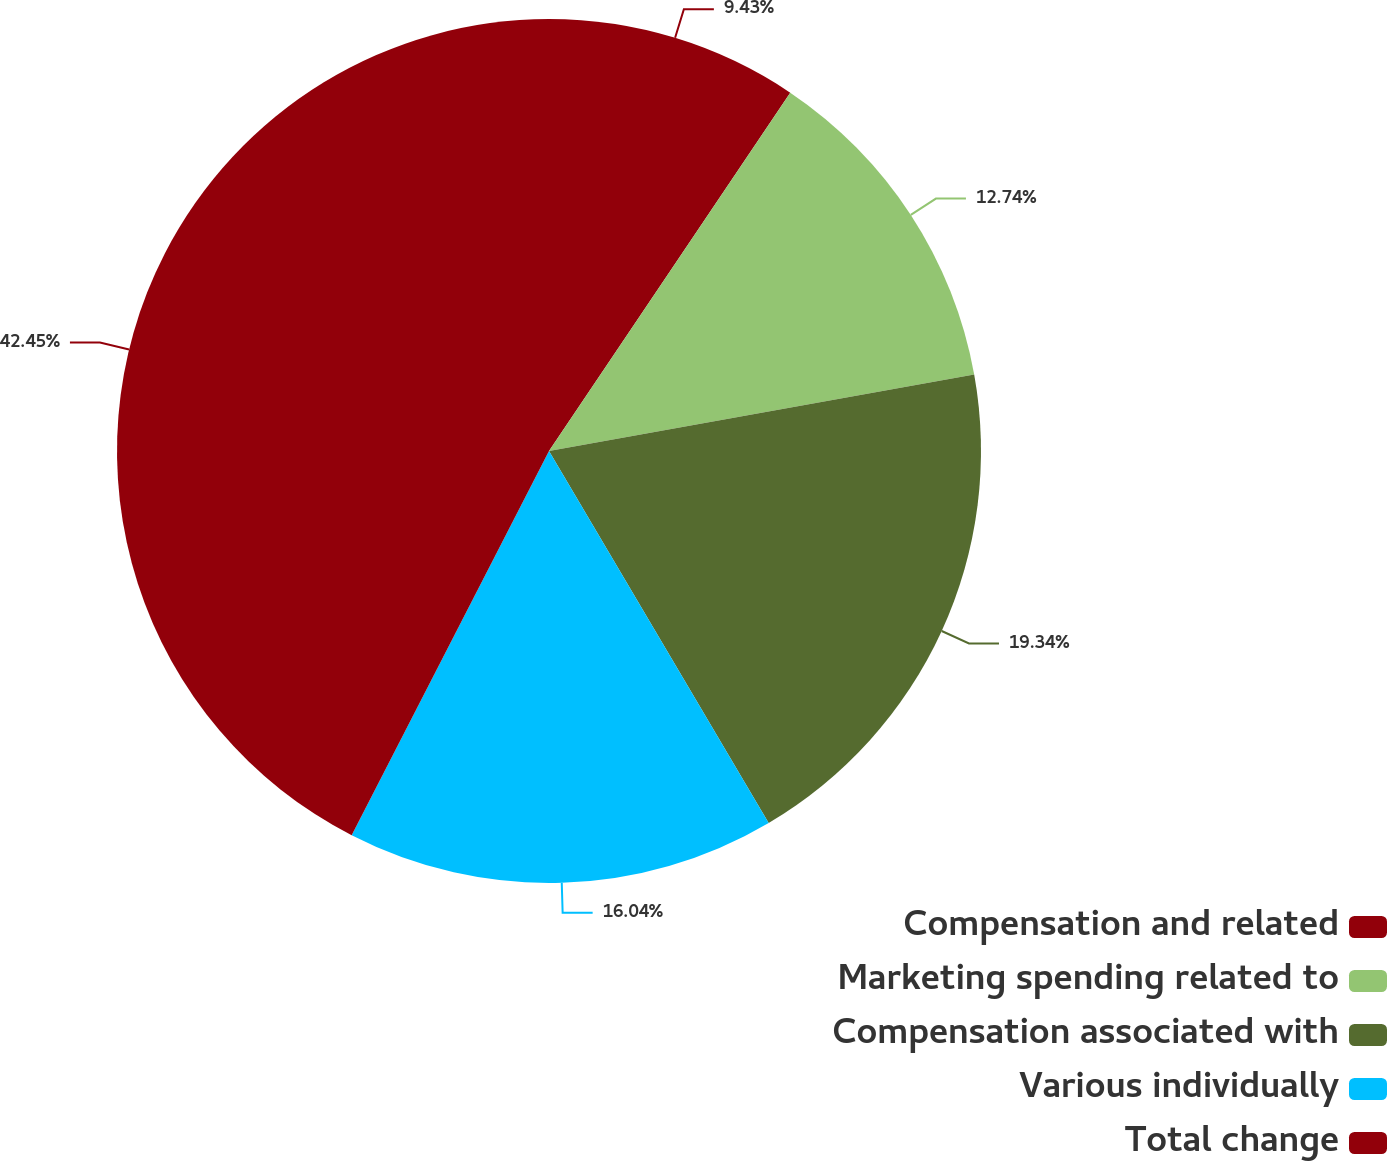Convert chart. <chart><loc_0><loc_0><loc_500><loc_500><pie_chart><fcel>Compensation and related<fcel>Marketing spending related to<fcel>Compensation associated with<fcel>Various individually<fcel>Total change<nl><fcel>9.43%<fcel>12.74%<fcel>19.34%<fcel>16.04%<fcel>42.45%<nl></chart> 